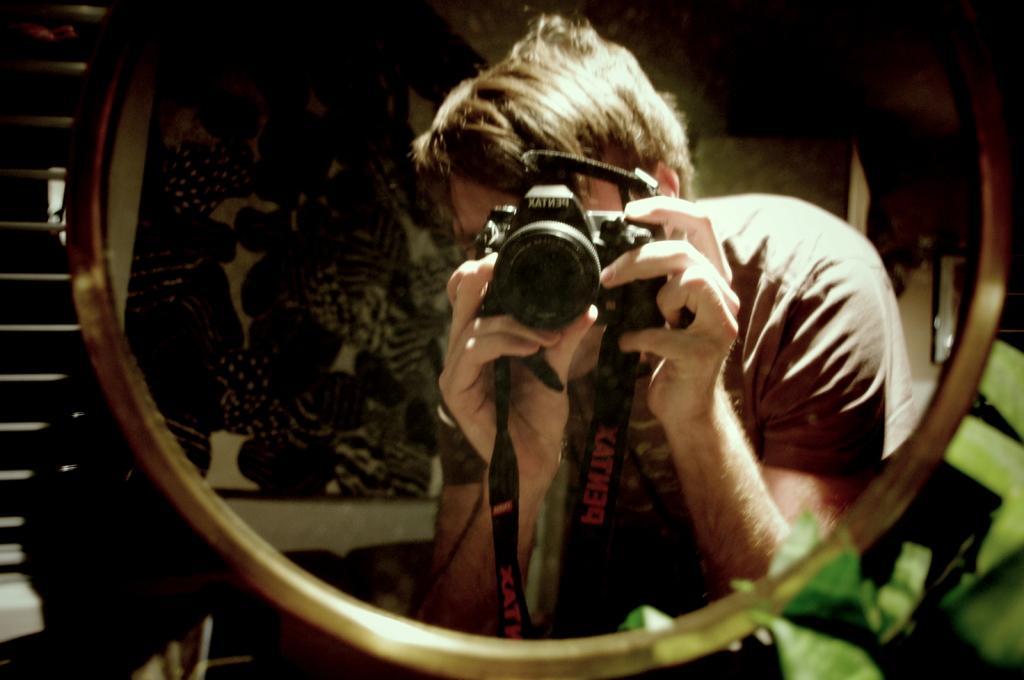Describe this image in one or two sentences. In this image we can see a person's reflection in the mirror by holding a camera and clicking a picture, on the left side of the image there are stairs, on the right side of the image there are leaves, behind the person there is a photo frame on the wall. 